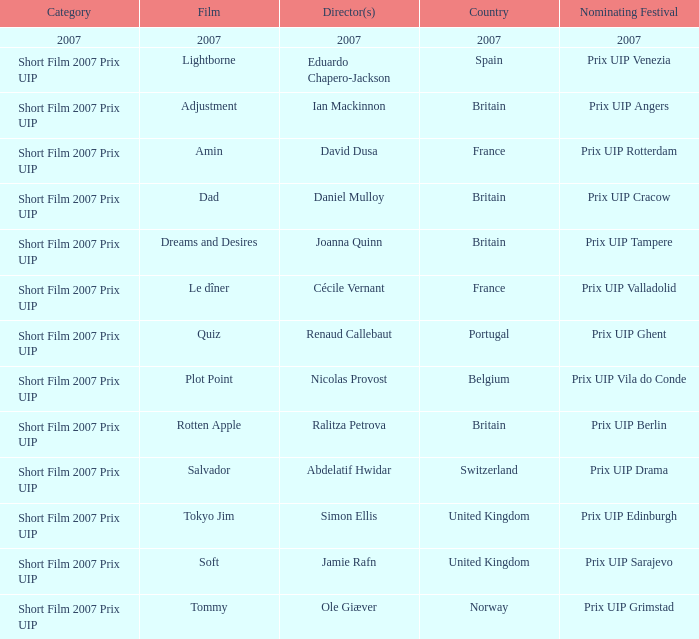Would you be able to parse every entry in this table? {'header': ['Category', 'Film', 'Director(s)', 'Country', 'Nominating Festival'], 'rows': [['2007', '2007', '2007', '2007', '2007'], ['Short Film 2007 Prix UIP', 'Lightborne', 'Eduardo Chapero-Jackson', 'Spain', 'Prix UIP Venezia'], ['Short Film 2007 Prix UIP', 'Adjustment', 'Ian Mackinnon', 'Britain', 'Prix UIP Angers'], ['Short Film 2007 Prix UIP', 'Amin', 'David Dusa', 'France', 'Prix UIP Rotterdam'], ['Short Film 2007 Prix UIP', 'Dad', 'Daniel Mulloy', 'Britain', 'Prix UIP Cracow'], ['Short Film 2007 Prix UIP', 'Dreams and Desires', 'Joanna Quinn', 'Britain', 'Prix UIP Tampere'], ['Short Film 2007 Prix UIP', 'Le dîner', 'Cécile Vernant', 'France', 'Prix UIP Valladolid'], ['Short Film 2007 Prix UIP', 'Quiz', 'Renaud Callebaut', 'Portugal', 'Prix UIP Ghent'], ['Short Film 2007 Prix UIP', 'Plot Point', 'Nicolas Provost', 'Belgium', 'Prix UIP Vila do Conde'], ['Short Film 2007 Prix UIP', 'Rotten Apple', 'Ralitza Petrova', 'Britain', 'Prix UIP Berlin'], ['Short Film 2007 Prix UIP', 'Salvador', 'Abdelatif Hwidar', 'Switzerland', 'Prix UIP Drama'], ['Short Film 2007 Prix UIP', 'Tokyo Jim', 'Simon Ellis', 'United Kingdom', 'Prix UIP Edinburgh'], ['Short Film 2007 Prix UIP', 'Soft', 'Jamie Rafn', 'United Kingdom', 'Prix UIP Sarajevo'], ['Short Film 2007 Prix UIP', 'Tommy', 'Ole Giæver', 'Norway', 'Prix UIP Grimstad']]} What country was the prix uip ghent nominating festival? Portugal. 